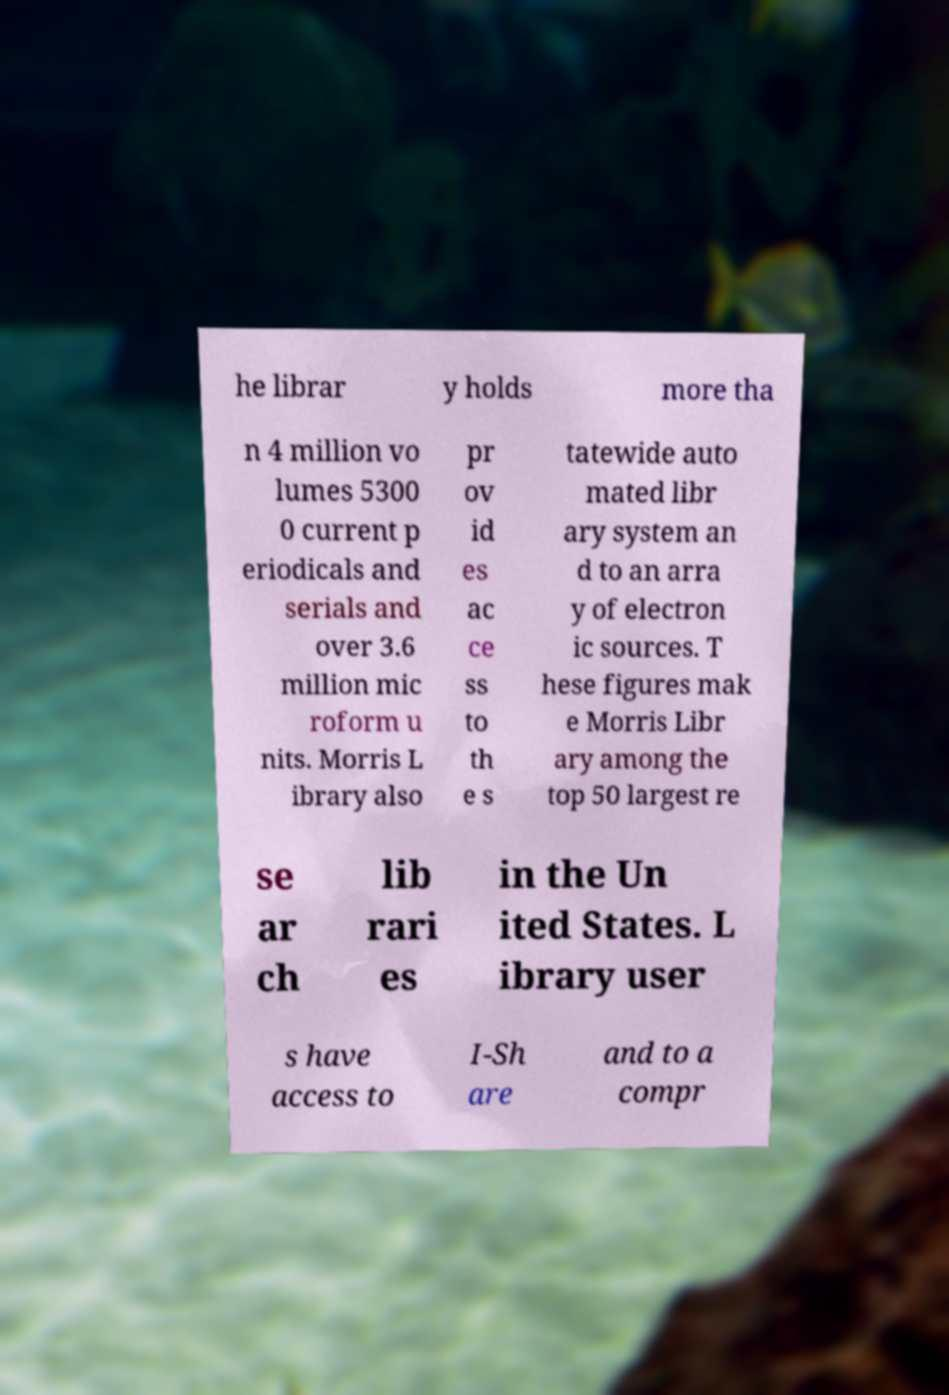Could you assist in decoding the text presented in this image and type it out clearly? he librar y holds more tha n 4 million vo lumes 5300 0 current p eriodicals and serials and over 3.6 million mic roform u nits. Morris L ibrary also pr ov id es ac ce ss to th e s tatewide auto mated libr ary system an d to an arra y of electron ic sources. T hese figures mak e Morris Libr ary among the top 50 largest re se ar ch lib rari es in the Un ited States. L ibrary user s have access to I-Sh are and to a compr 